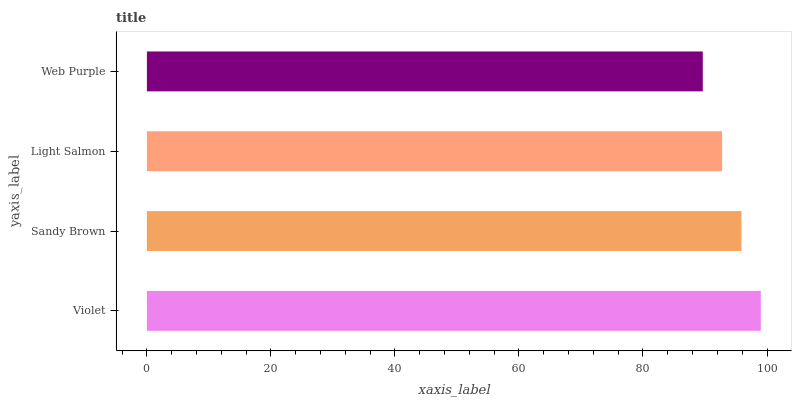Is Web Purple the minimum?
Answer yes or no. Yes. Is Violet the maximum?
Answer yes or no. Yes. Is Sandy Brown the minimum?
Answer yes or no. No. Is Sandy Brown the maximum?
Answer yes or no. No. Is Violet greater than Sandy Brown?
Answer yes or no. Yes. Is Sandy Brown less than Violet?
Answer yes or no. Yes. Is Sandy Brown greater than Violet?
Answer yes or no. No. Is Violet less than Sandy Brown?
Answer yes or no. No. Is Sandy Brown the high median?
Answer yes or no. Yes. Is Light Salmon the low median?
Answer yes or no. Yes. Is Web Purple the high median?
Answer yes or no. No. Is Violet the low median?
Answer yes or no. No. 